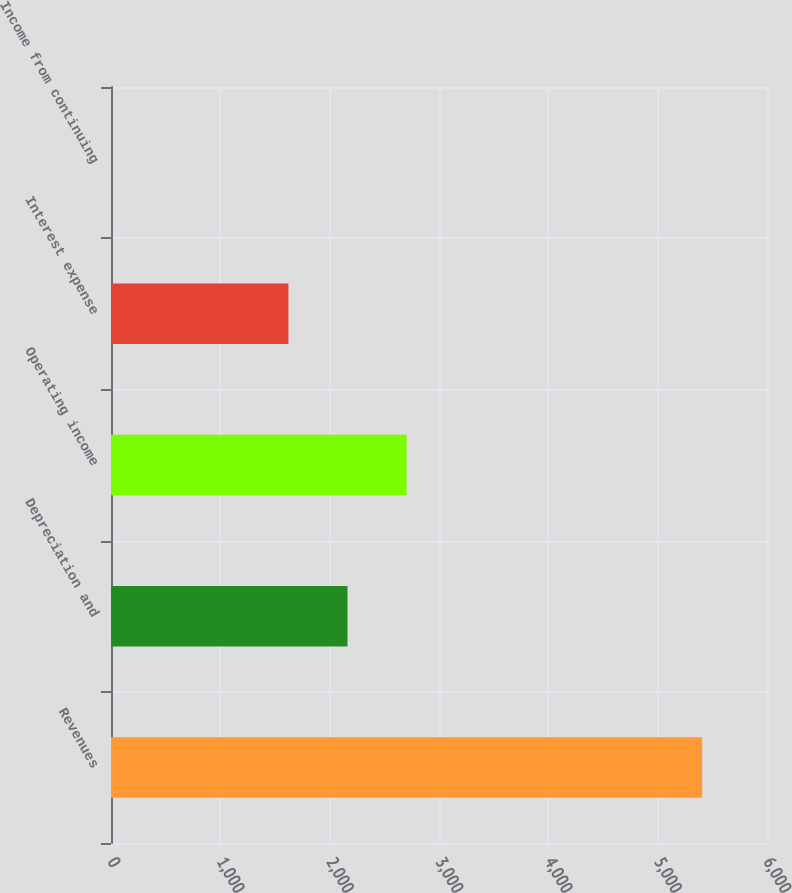Convert chart. <chart><loc_0><loc_0><loc_500><loc_500><bar_chart><fcel>Revenues<fcel>Depreciation and<fcel>Operating income<fcel>Interest expense<fcel>Income from continuing<nl><fcel>5407<fcel>2163.18<fcel>2703.81<fcel>1622.55<fcel>0.66<nl></chart> 